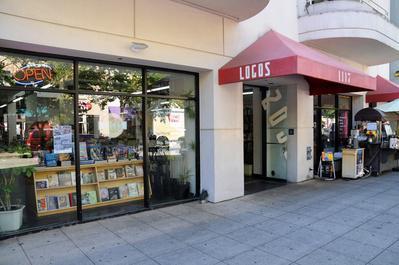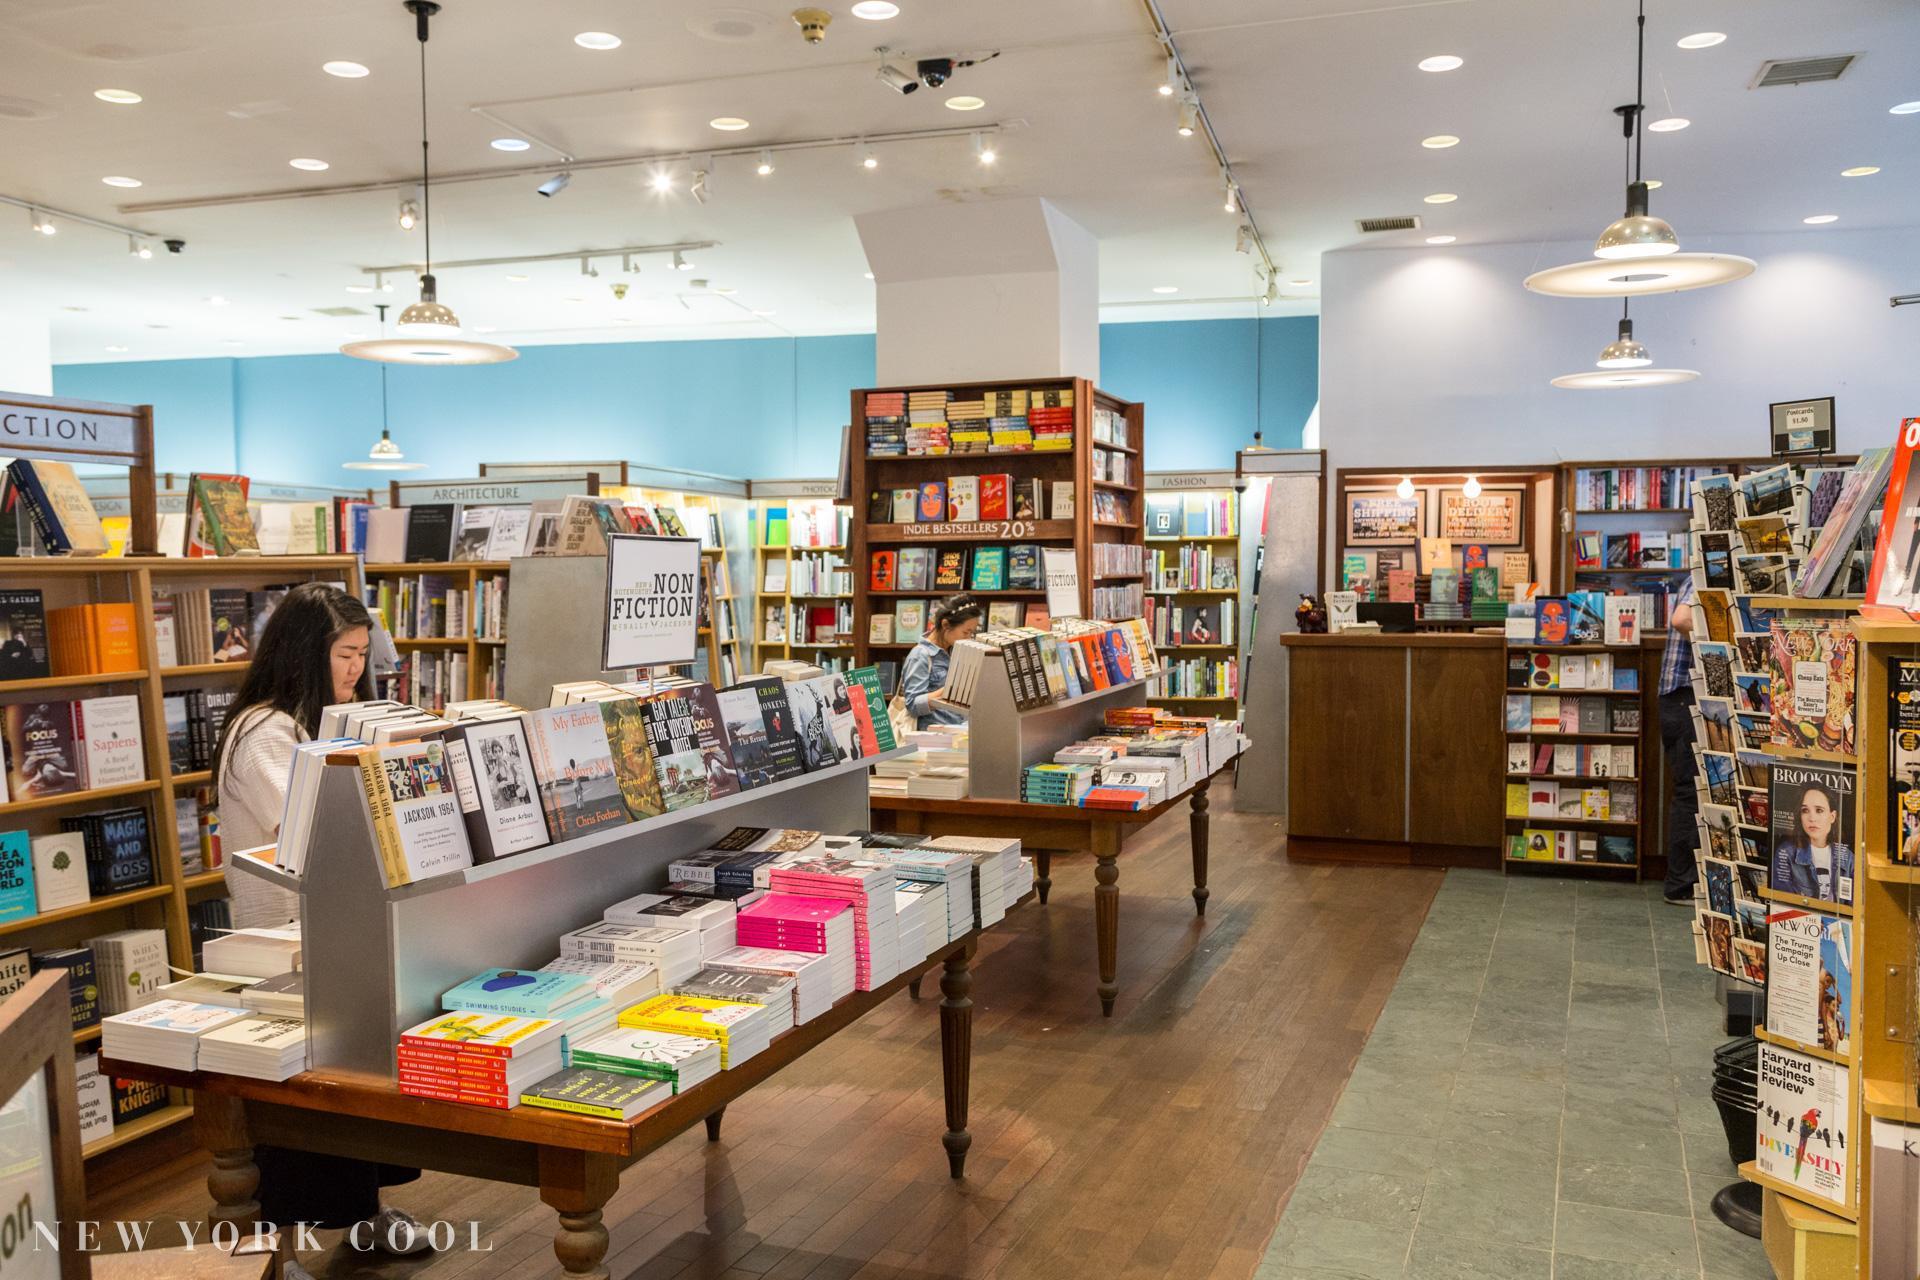The first image is the image on the left, the second image is the image on the right. Considering the images on both sides, is "There is a person in at least one of the photos." valid? Answer yes or no. Yes. The first image is the image on the left, the second image is the image on the right. Examine the images to the left and right. Is the description "There is 1 or more person(s) browsing the book selections." accurate? Answer yes or no. Yes. 